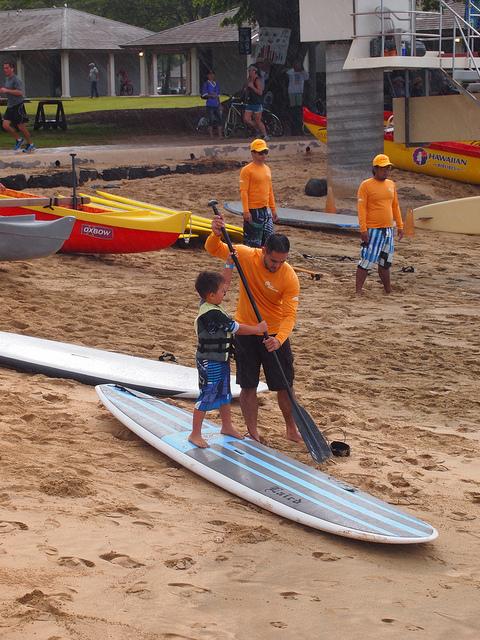What is the boy learning to do?
Give a very brief answer. Surf. How many people are wearing orange shirts?
Quick response, please. 3. Are these yellow items in the right place?
Be succinct. Yes. Is it raining?
Concise answer only. No. 